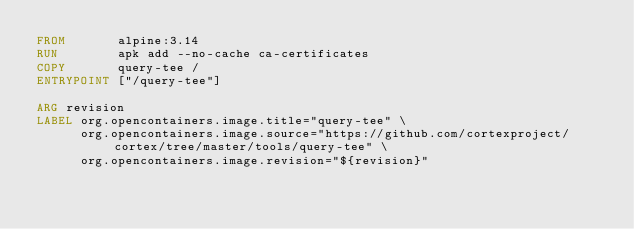<code> <loc_0><loc_0><loc_500><loc_500><_Dockerfile_>FROM       alpine:3.14
RUN        apk add --no-cache ca-certificates
COPY       query-tee /
ENTRYPOINT ["/query-tee"]

ARG revision
LABEL org.opencontainers.image.title="query-tee" \
      org.opencontainers.image.source="https://github.com/cortexproject/cortex/tree/master/tools/query-tee" \
      org.opencontainers.image.revision="${revision}"
</code> 